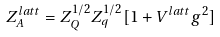Convert formula to latex. <formula><loc_0><loc_0><loc_500><loc_500>Z _ { A } ^ { l a t t } = Z _ { Q } ^ { 1 / 2 } Z _ { q } ^ { 1 / 2 } [ 1 + V ^ { l a t t } g ^ { 2 } ]</formula> 